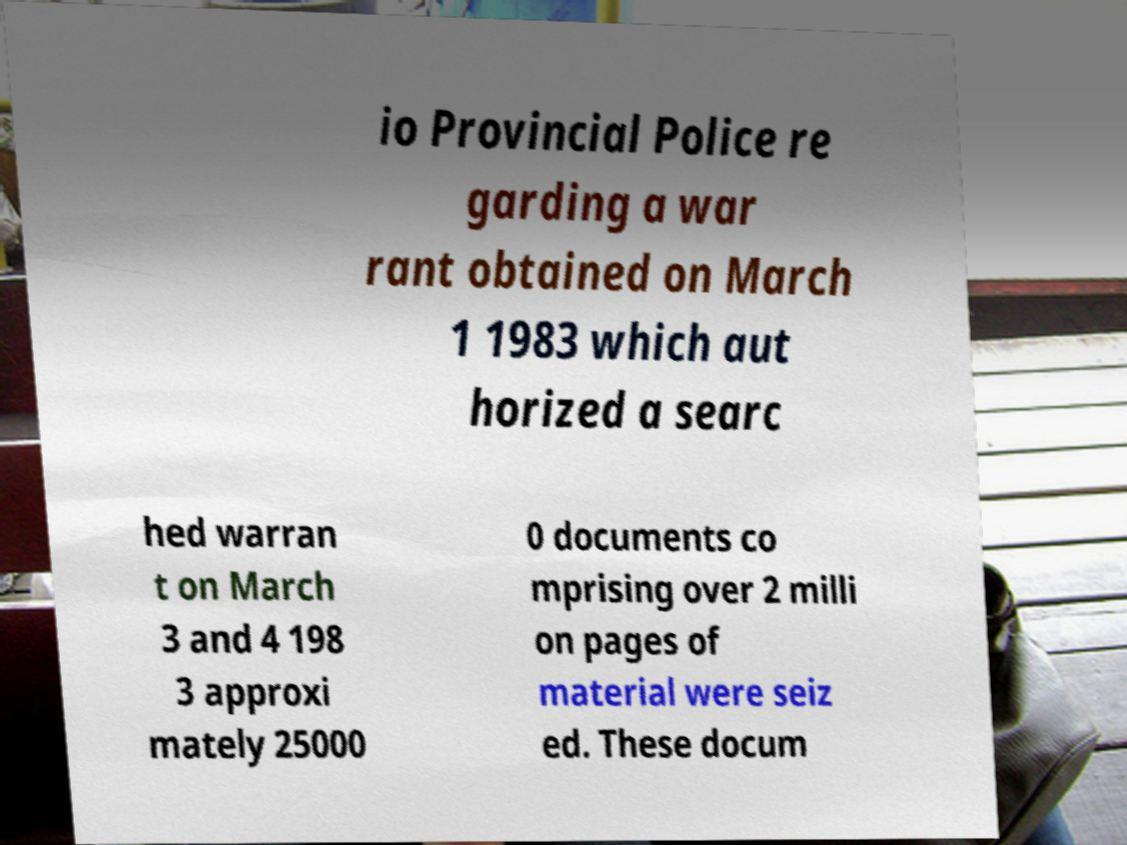Please read and relay the text visible in this image. What does it say? io Provincial Police re garding a war rant obtained on March 1 1983 which aut horized a searc hed warran t on March 3 and 4 198 3 approxi mately 25000 0 documents co mprising over 2 milli on pages of material were seiz ed. These docum 